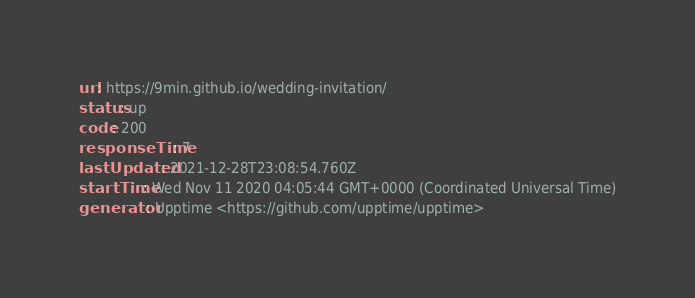<code> <loc_0><loc_0><loc_500><loc_500><_YAML_>url: https://9min.github.io/wedding-invitation/
status: up
code: 200
responseTime: 7
lastUpdated: 2021-12-28T23:08:54.760Z
startTime: Wed Nov 11 2020 04:05:44 GMT+0000 (Coordinated Universal Time)
generator: Upptime <https://github.com/upptime/upptime>
</code> 